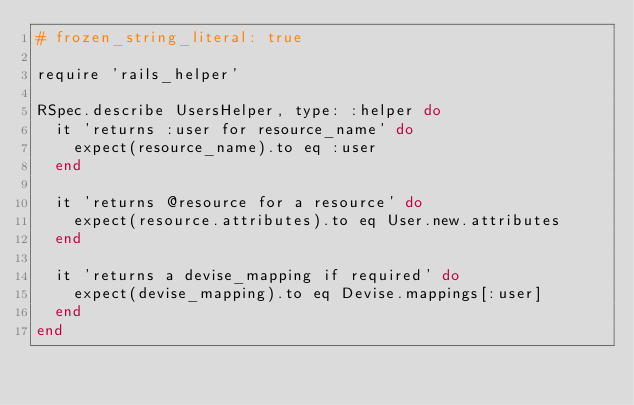Convert code to text. <code><loc_0><loc_0><loc_500><loc_500><_Ruby_># frozen_string_literal: true

require 'rails_helper'

RSpec.describe UsersHelper, type: :helper do
  it 'returns :user for resource_name' do
    expect(resource_name).to eq :user
  end

  it 'returns @resource for a resource' do
    expect(resource.attributes).to eq User.new.attributes
  end

  it 'returns a devise_mapping if required' do
    expect(devise_mapping).to eq Devise.mappings[:user]
  end
end
</code> 